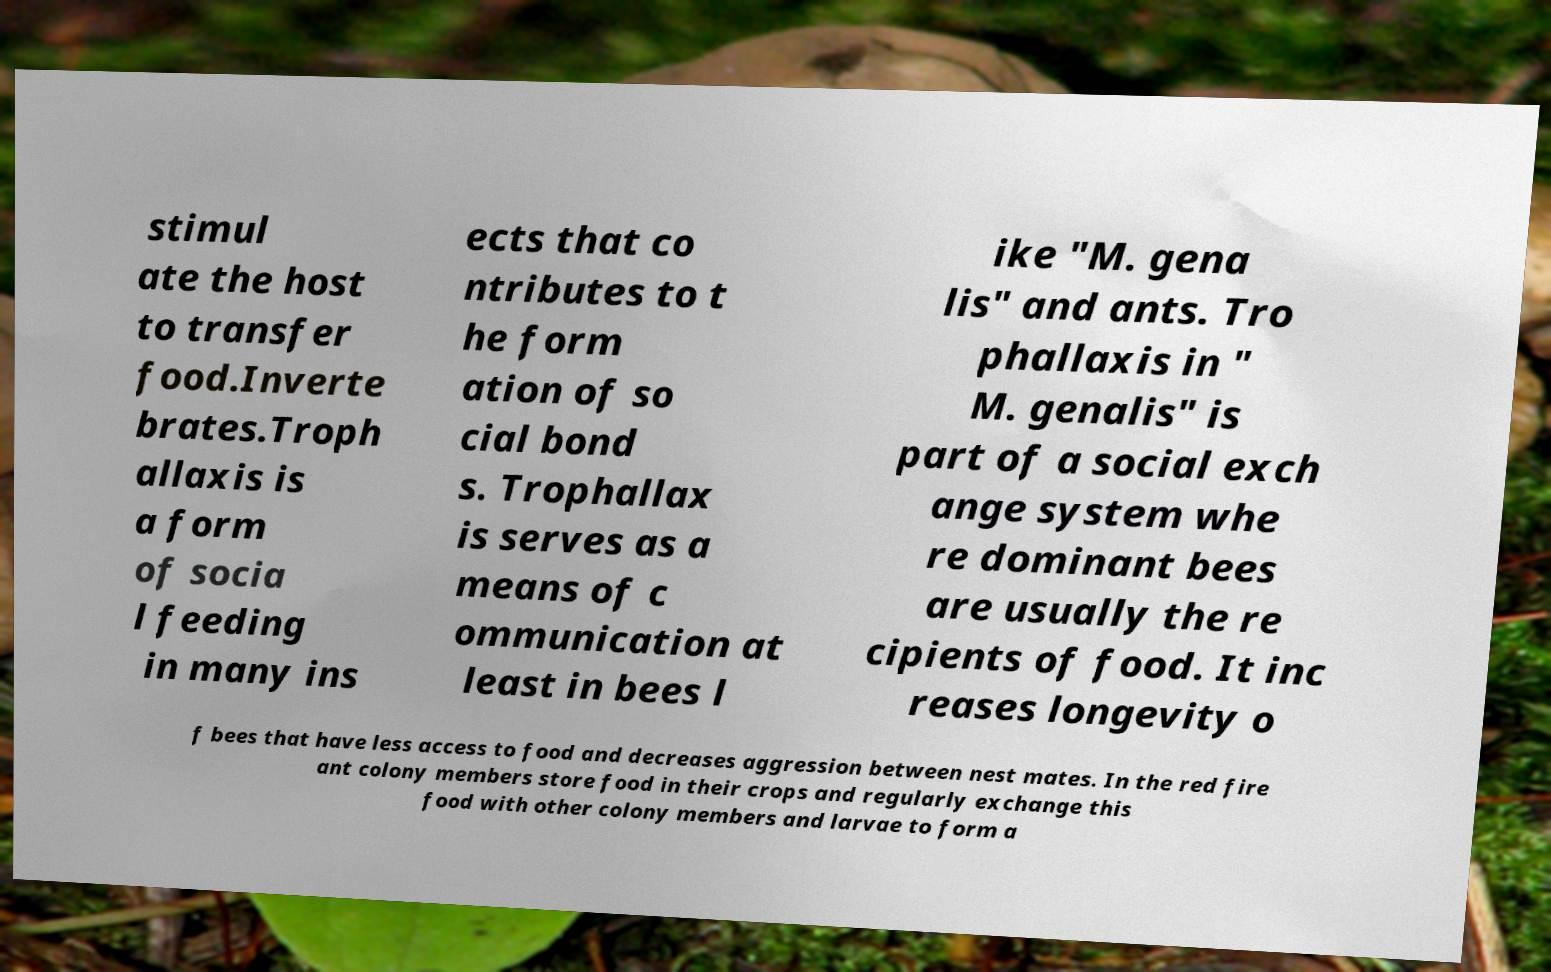Can you accurately transcribe the text from the provided image for me? stimul ate the host to transfer food.Inverte brates.Troph allaxis is a form of socia l feeding in many ins ects that co ntributes to t he form ation of so cial bond s. Trophallax is serves as a means of c ommunication at least in bees l ike "M. gena lis" and ants. Tro phallaxis in " M. genalis" is part of a social exch ange system whe re dominant bees are usually the re cipients of food. It inc reases longevity o f bees that have less access to food and decreases aggression between nest mates. In the red fire ant colony members store food in their crops and regularly exchange this food with other colony members and larvae to form a 